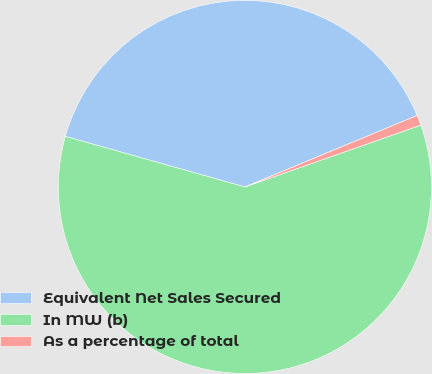Convert chart to OTSL. <chart><loc_0><loc_0><loc_500><loc_500><pie_chart><fcel>Equivalent Net Sales Secured<fcel>In MW (b)<fcel>As a percentage of total<nl><fcel>39.37%<fcel>59.75%<fcel>0.88%<nl></chart> 